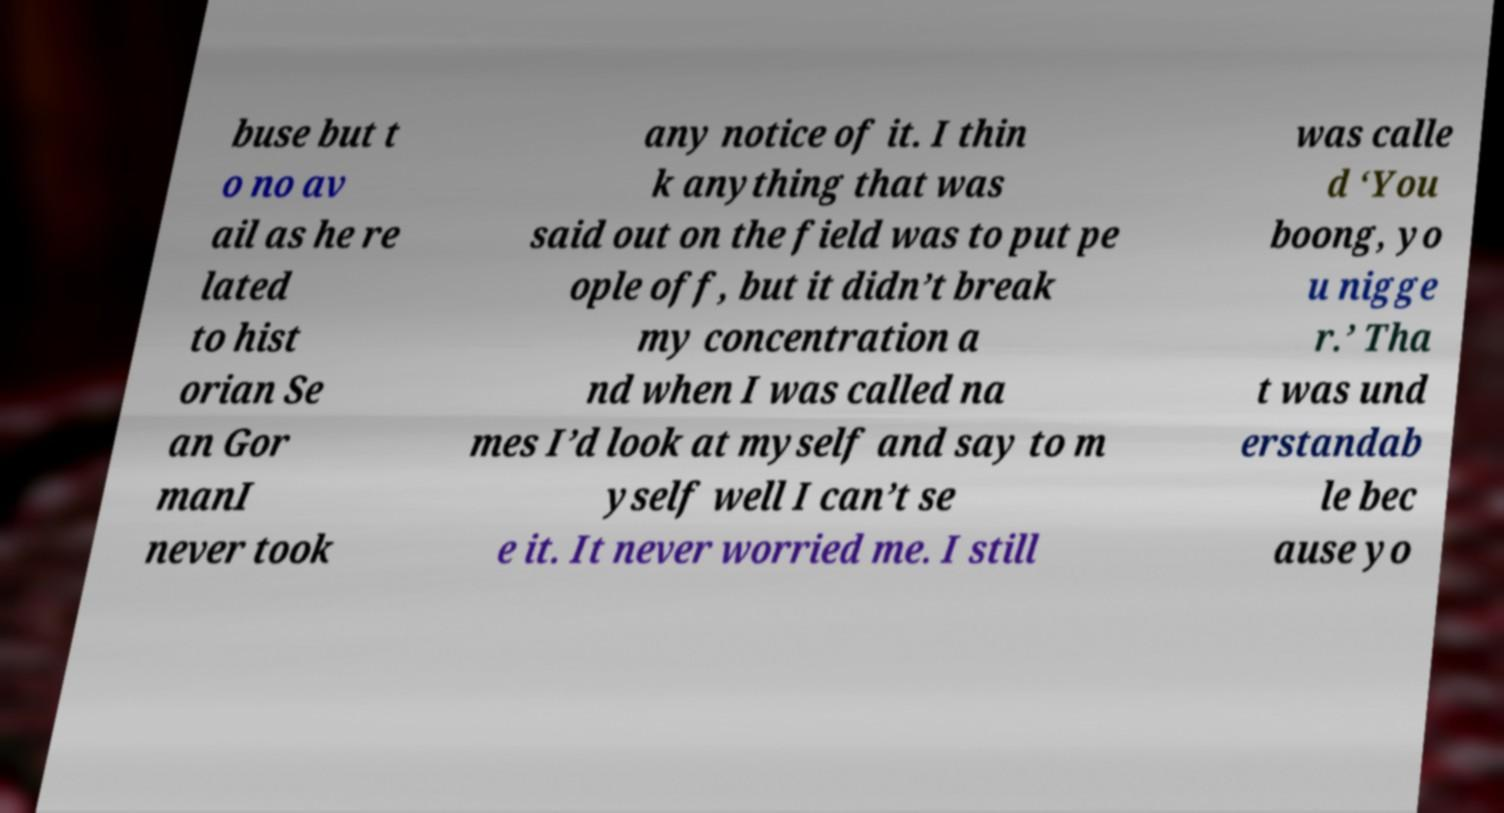For documentation purposes, I need the text within this image transcribed. Could you provide that? buse but t o no av ail as he re lated to hist orian Se an Gor manI never took any notice of it. I thin k anything that was said out on the field was to put pe ople off, but it didn’t break my concentration a nd when I was called na mes I’d look at myself and say to m yself well I can’t se e it. It never worried me. I still was calle d ‘You boong, yo u nigge r.’ Tha t was und erstandab le bec ause yo 